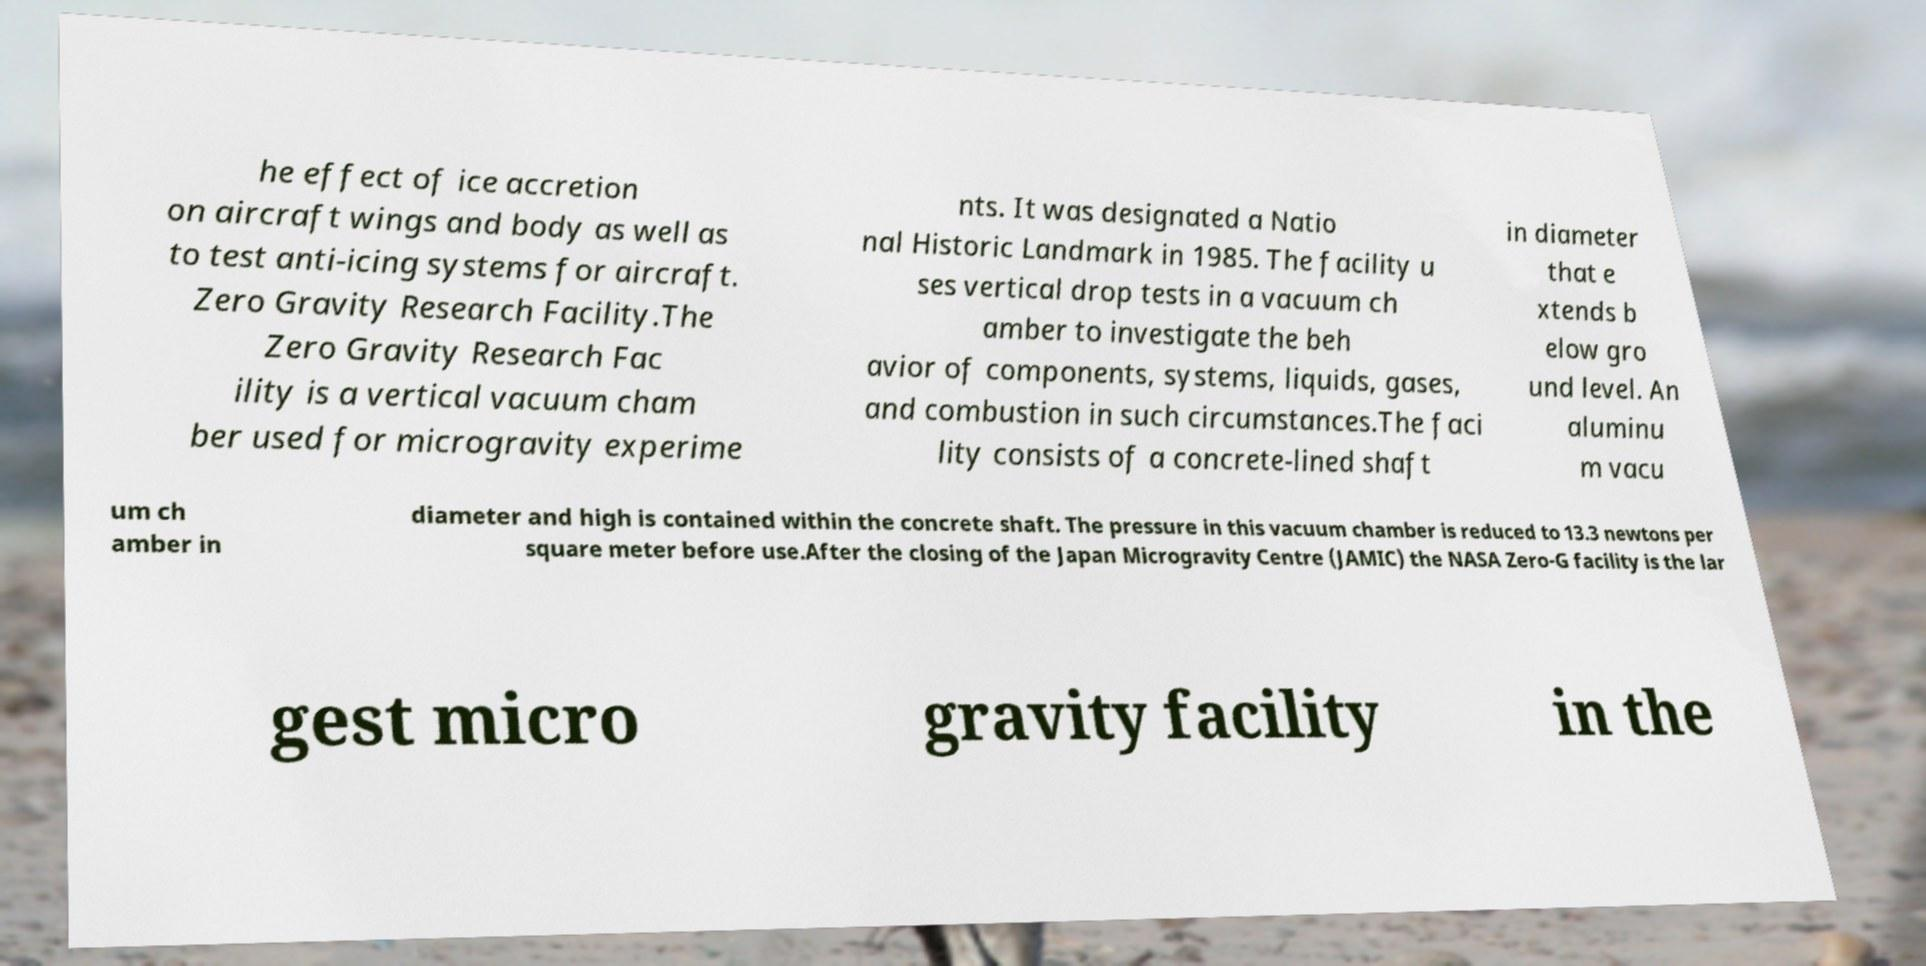I need the written content from this picture converted into text. Can you do that? he effect of ice accretion on aircraft wings and body as well as to test anti-icing systems for aircraft. Zero Gravity Research Facility.The Zero Gravity Research Fac ility is a vertical vacuum cham ber used for microgravity experime nts. It was designated a Natio nal Historic Landmark in 1985. The facility u ses vertical drop tests in a vacuum ch amber to investigate the beh avior of components, systems, liquids, gases, and combustion in such circumstances.The faci lity consists of a concrete-lined shaft in diameter that e xtends b elow gro und level. An aluminu m vacu um ch amber in diameter and high is contained within the concrete shaft. The pressure in this vacuum chamber is reduced to 13.3 newtons per square meter before use.After the closing of the Japan Microgravity Centre (JAMIC) the NASA Zero-G facility is the lar gest micro gravity facility in the 